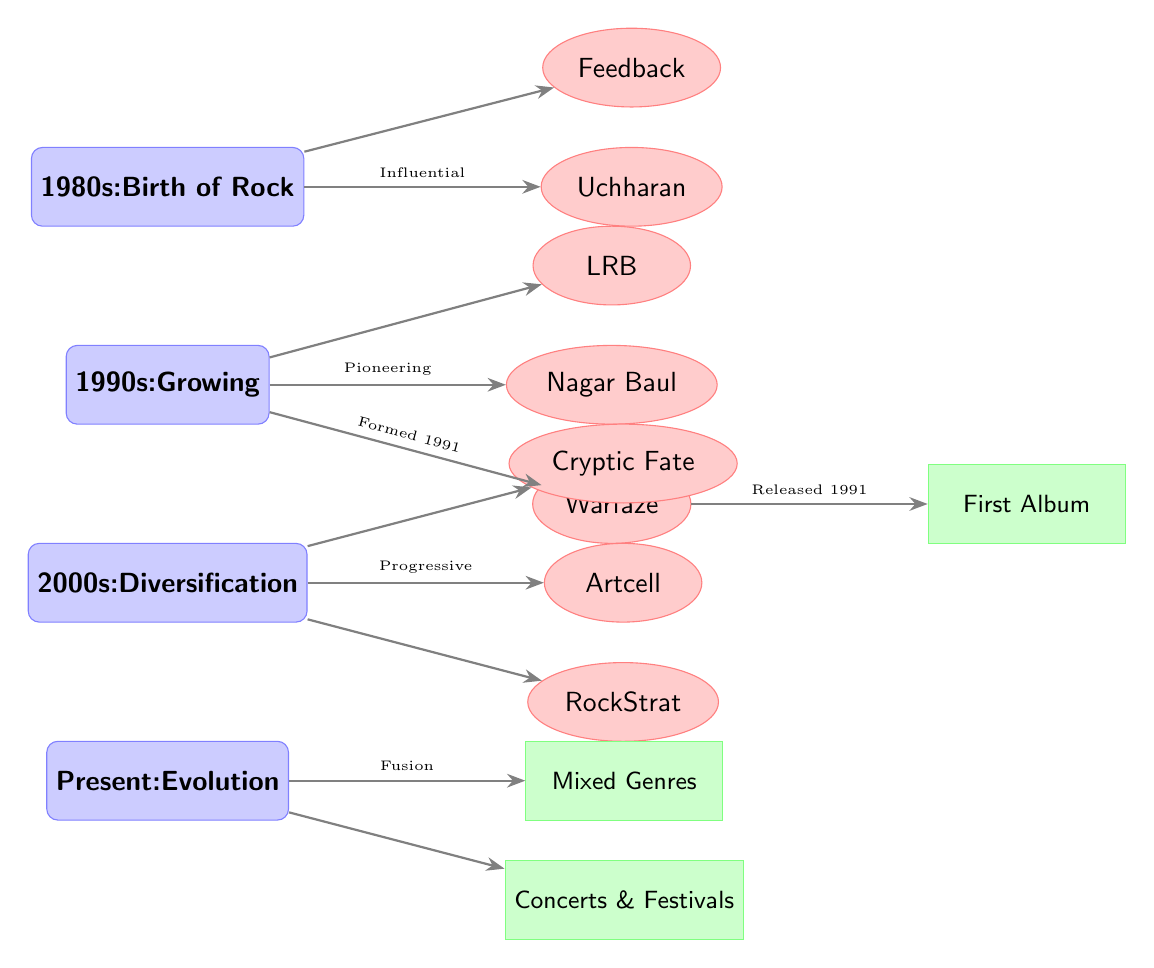What is the earliest era represented in the diagram? The diagram's vertical arrangement states that the first era at the top is the "1980s: Birth of Rock," which indicates it is the earliest.
Answer: 1980s: Birth of Rock How many bands are associated with the 1990s era? By analyzing the 1990s node, it connects to three bands: Nagar Baul, LRB, and Warfaze, thus totaling three bands under this era.
Answer: 3 Which band is directly linked to the milestone of "First Album"? Starting from the Warfaze node in the 1990s, an arrow connects it directly to the milestone node labeled "First Album."
Answer: Warfaze Which band is known for its progressive rock style during the 2000s? The band Artcell is specifically labeled as "Progressive," linking it directly to the 2000s era.
Answer: Artcell What relationship does Warfaze have with the milestone "Released 1991"? The diagram shows a direct connection with an arrow from the Warfaze band node to the milestone labeled "Released 1991," indicating that Warfaze is the band that released music in that year.
Answer: Warfaze Which milestone is associated with the present era? In the Present era section, there are two milestones, but "Mixed Genres" is positioned at the top of the section and thus is a significant milestone for the present.
Answer: Mixed Genres What type of music influence is represented in the 1980s? The description of the era in the diagram specifically shows the term "Birth of Rock," indicating the type of music that influenced this period.
Answer: Rock How many total bands are listed in the diagram? Counting the bands across all eras, the list includes Uchharan, Feedback, Nagar Baul, LRB, Warfaze, Artcell, Cryptic Fate, and RockStrat, totaling eight bands.
Answer: 8 What is the significance of the arrow connecting Warfaze to its first album? The arrow signifies that Warfaze is not just a band from the 1990s, but also highlights its achievement of releasing its first album in 1991, marking a key milestone.
Answer: First Album What aspect of Bangladeshi rock music does the present era emphasize? The present era indicates an evolution in style through the milestones listed, such as "Mixed Genres" and "Concerts & Festivals," suggesting a broader diversity in performance and genre blending.
Answer: Fusion 